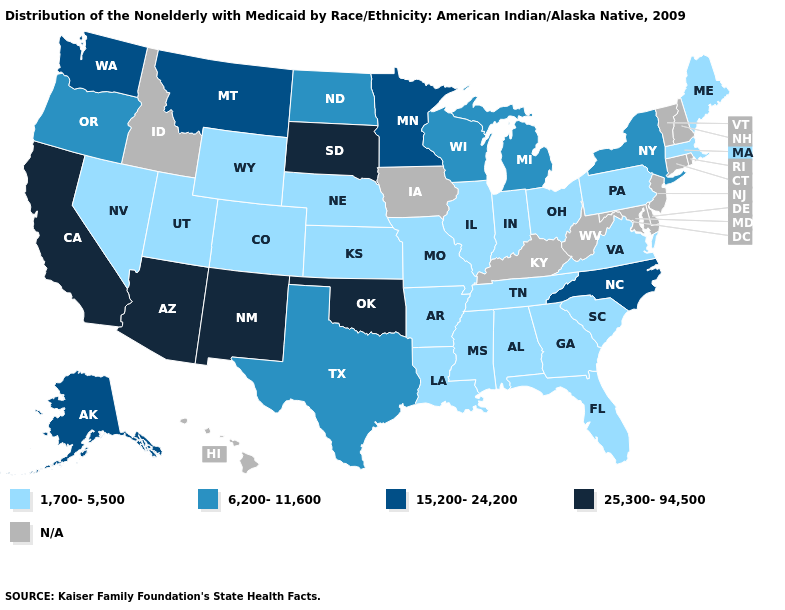Among the states that border Mississippi , which have the lowest value?
Write a very short answer. Alabama, Arkansas, Louisiana, Tennessee. Which states have the lowest value in the MidWest?
Give a very brief answer. Illinois, Indiana, Kansas, Missouri, Nebraska, Ohio. Name the states that have a value in the range 6,200-11,600?
Answer briefly. Michigan, New York, North Dakota, Oregon, Texas, Wisconsin. Which states have the lowest value in the USA?
Quick response, please. Alabama, Arkansas, Colorado, Florida, Georgia, Illinois, Indiana, Kansas, Louisiana, Maine, Massachusetts, Mississippi, Missouri, Nebraska, Nevada, Ohio, Pennsylvania, South Carolina, Tennessee, Utah, Virginia, Wyoming. Name the states that have a value in the range 15,200-24,200?
Keep it brief. Alaska, Minnesota, Montana, North Carolina, Washington. What is the value of Massachusetts?
Quick response, please. 1,700-5,500. What is the value of North Dakota?
Short answer required. 6,200-11,600. Among the states that border Arizona , does Colorado have the lowest value?
Answer briefly. Yes. What is the lowest value in the USA?
Keep it brief. 1,700-5,500. What is the lowest value in the USA?
Short answer required. 1,700-5,500. What is the value of New Hampshire?
Answer briefly. N/A. Does New Mexico have the lowest value in the USA?
Write a very short answer. No. What is the value of Maryland?
Keep it brief. N/A. 